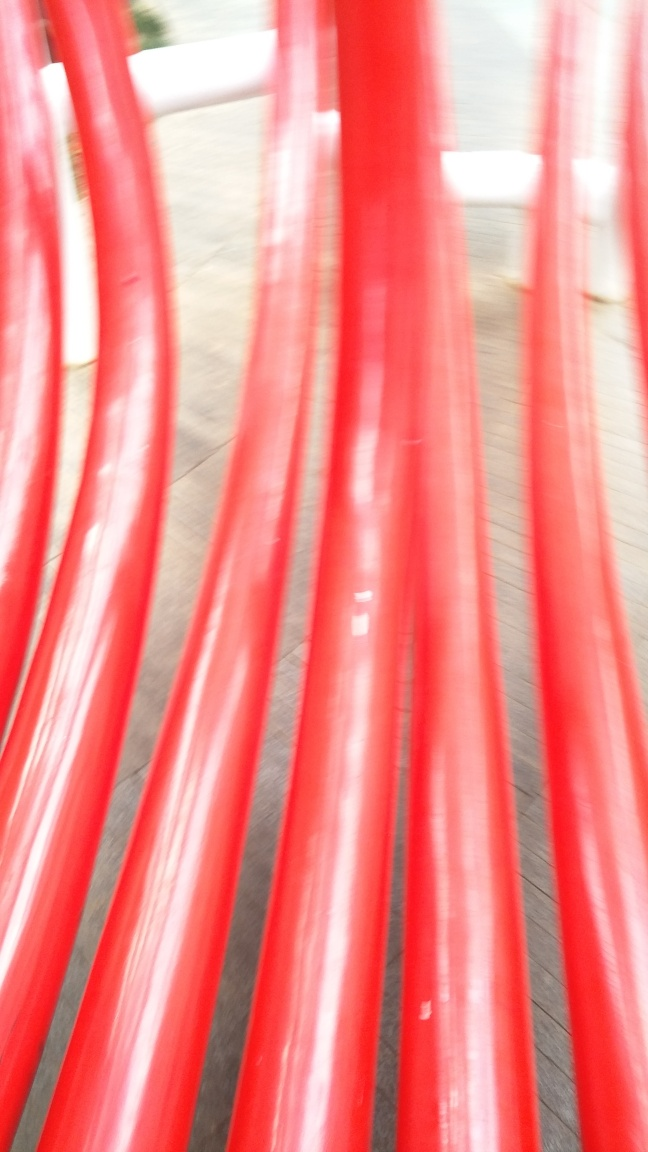What time of day does this image appear to have been captured? The lighting in the image appears to be diffused, potentially indicating an overcast day or a time when the sun position doesn't create harsh shadows. However, it's not possible to accurately deduce the exact time of day from the current image quality. 